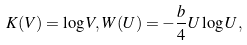Convert formula to latex. <formula><loc_0><loc_0><loc_500><loc_500>K ( V ) = \log V , W ( U ) = - \frac { b } { 4 } U \log U ,</formula> 